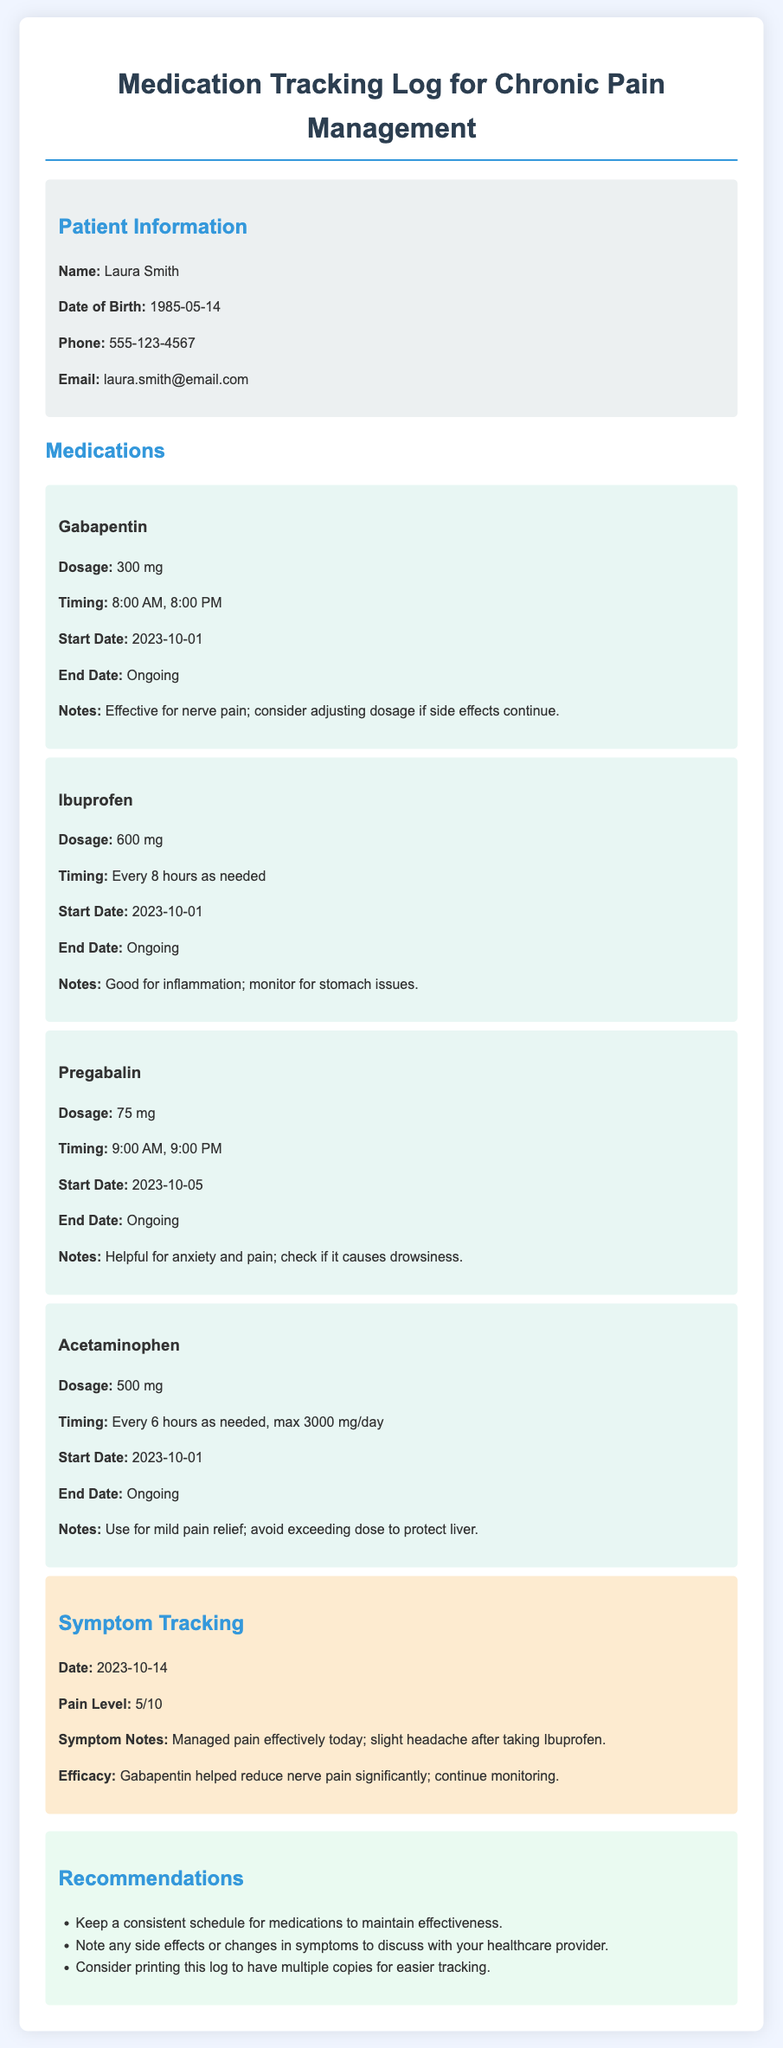what is the name of the patient? The patient's name is mentioned under patient information in the document.
Answer: Laura Smith what is the dosage of Gabapentin? The dosage of Gabapentin is specified in the medication section of the document.
Answer: 300 mg what are the times for taking Pregabalin? The medication timing for Pregabalin is indicated in the document under its specific section.
Answer: 9:00 AM, 9:00 PM when did the patient start taking Ibuprofen? The start date for Ibuprofen is listed in the medication details provided in the document.
Answer: 2023-10-01 what side effect should be monitored for Ibuprofen? The document notes potential side effects to watch for with Ibuprofen.
Answer: Stomach issues which medication is used for nerve pain? The document describes medications along with their effectiveness in treating pain.
Answer: Gabapentin what was the pain level reported on 2023-10-14? The specific pain level is mentioned in the symptom tracking section of the document.
Answer: 5/10 what recommendation is given for medication scheduling? Recommendations for taking medications consistently are provided in the document.
Answer: Keep a consistent schedule what was noted about the efficacy of Gabapentin? Efficacy notes detail the effectiveness of medications in the document.
Answer: Helped reduce nerve pain significantly 